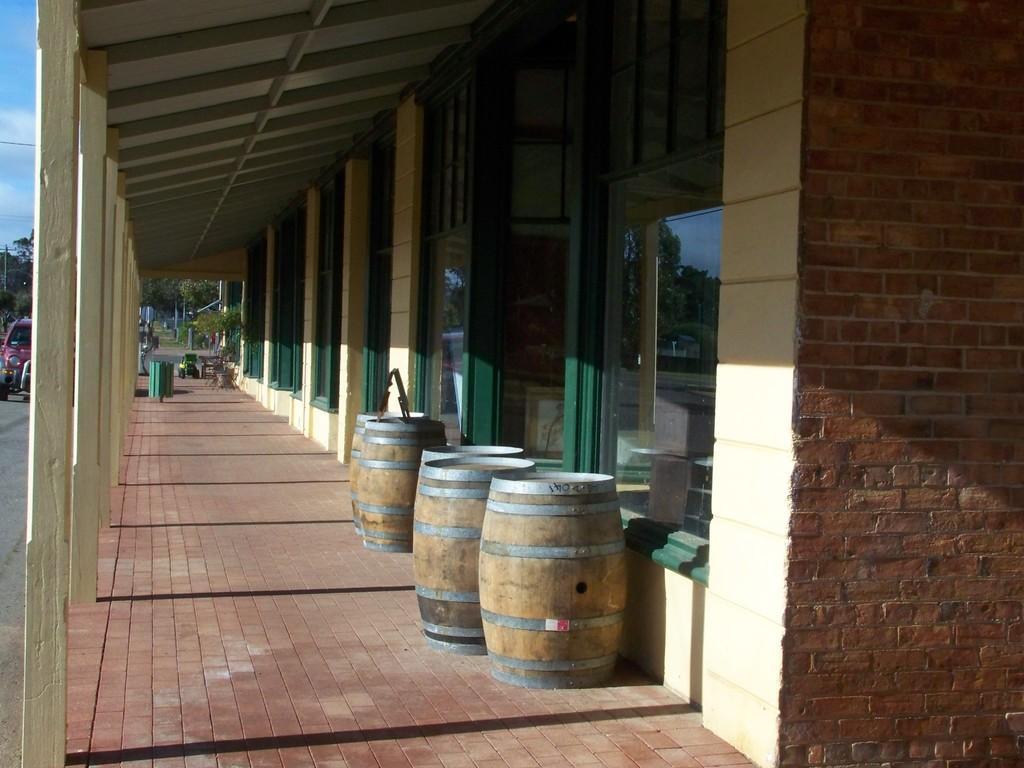Describe this image in one or two sentences. In this image we can see a building with the wooden poles and some windows. We can also see some barrels, a container and some objects placed under a roof. On the left side we can see some vehicles on the road, some trees, a wire and the sky. 